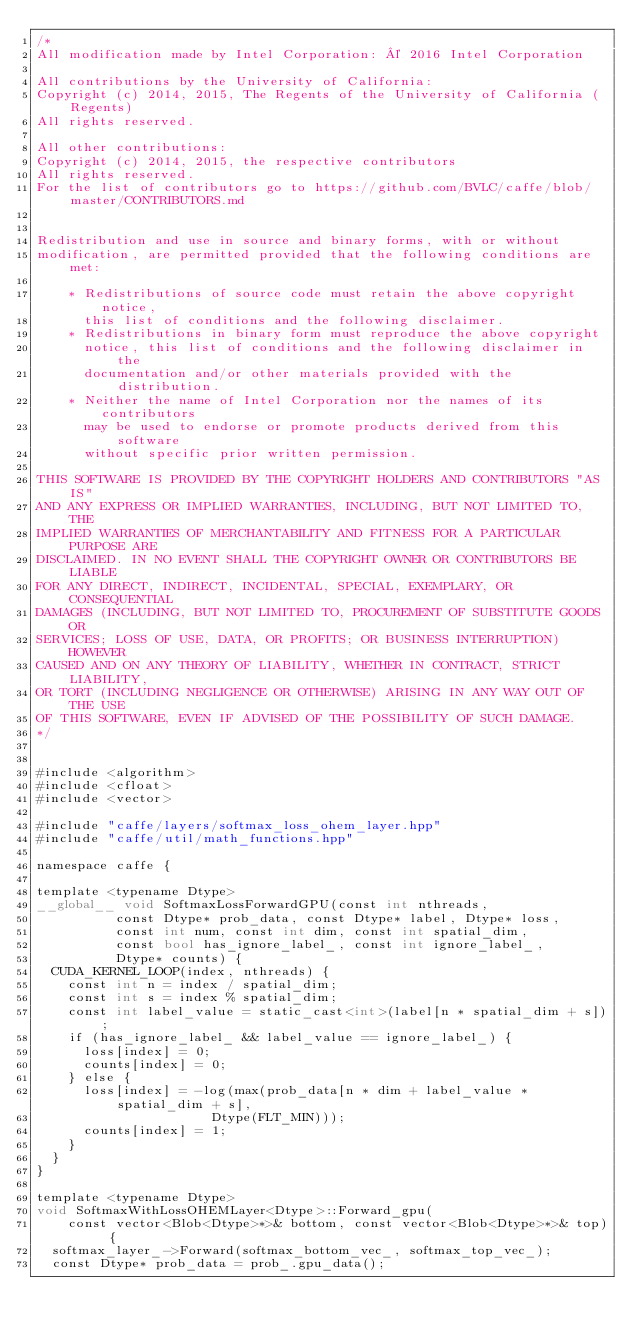<code> <loc_0><loc_0><loc_500><loc_500><_Cuda_>/*
All modification made by Intel Corporation: © 2016 Intel Corporation

All contributions by the University of California:
Copyright (c) 2014, 2015, The Regents of the University of California (Regents)
All rights reserved.

All other contributions:
Copyright (c) 2014, 2015, the respective contributors
All rights reserved.
For the list of contributors go to https://github.com/BVLC/caffe/blob/master/CONTRIBUTORS.md


Redistribution and use in source and binary forms, with or without
modification, are permitted provided that the following conditions are met:

    * Redistributions of source code must retain the above copyright notice,
      this list of conditions and the following disclaimer.
    * Redistributions in binary form must reproduce the above copyright
      notice, this list of conditions and the following disclaimer in the
      documentation and/or other materials provided with the distribution.
    * Neither the name of Intel Corporation nor the names of its contributors
      may be used to endorse or promote products derived from this software
      without specific prior written permission.

THIS SOFTWARE IS PROVIDED BY THE COPYRIGHT HOLDERS AND CONTRIBUTORS "AS IS"
AND ANY EXPRESS OR IMPLIED WARRANTIES, INCLUDING, BUT NOT LIMITED TO, THE
IMPLIED WARRANTIES OF MERCHANTABILITY AND FITNESS FOR A PARTICULAR PURPOSE ARE
DISCLAIMED. IN NO EVENT SHALL THE COPYRIGHT OWNER OR CONTRIBUTORS BE LIABLE
FOR ANY DIRECT, INDIRECT, INCIDENTAL, SPECIAL, EXEMPLARY, OR CONSEQUENTIAL
DAMAGES (INCLUDING, BUT NOT LIMITED TO, PROCUREMENT OF SUBSTITUTE GOODS OR
SERVICES; LOSS OF USE, DATA, OR PROFITS; OR BUSINESS INTERRUPTION) HOWEVER
CAUSED AND ON ANY THEORY OF LIABILITY, WHETHER IN CONTRACT, STRICT LIABILITY,
OR TORT (INCLUDING NEGLIGENCE OR OTHERWISE) ARISING IN ANY WAY OUT OF THE USE
OF THIS SOFTWARE, EVEN IF ADVISED OF THE POSSIBILITY OF SUCH DAMAGE.
*/


#include <algorithm>
#include <cfloat>
#include <vector>

#include "caffe/layers/softmax_loss_ohem_layer.hpp"
#include "caffe/util/math_functions.hpp"

namespace caffe {

template <typename Dtype>
__global__ void SoftmaxLossForwardGPU(const int nthreads,
          const Dtype* prob_data, const Dtype* label, Dtype* loss,
          const int num, const int dim, const int spatial_dim,
          const bool has_ignore_label_, const int ignore_label_,
          Dtype* counts) {
  CUDA_KERNEL_LOOP(index, nthreads) {
    const int n = index / spatial_dim;
    const int s = index % spatial_dim;
    const int label_value = static_cast<int>(label[n * spatial_dim + s]);
    if (has_ignore_label_ && label_value == ignore_label_) {
      loss[index] = 0;
      counts[index] = 0;
    } else {
      loss[index] = -log(max(prob_data[n * dim + label_value * spatial_dim + s],
                      Dtype(FLT_MIN)));
      counts[index] = 1;
    }
  }
}

template <typename Dtype>
void SoftmaxWithLossOHEMLayer<Dtype>::Forward_gpu(
    const vector<Blob<Dtype>*>& bottom, const vector<Blob<Dtype>*>& top) {
  softmax_layer_->Forward(softmax_bottom_vec_, softmax_top_vec_);
  const Dtype* prob_data = prob_.gpu_data();</code> 